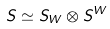Convert formula to latex. <formula><loc_0><loc_0><loc_500><loc_500>S \simeq S _ { W } \otimes S ^ { W } \,</formula> 